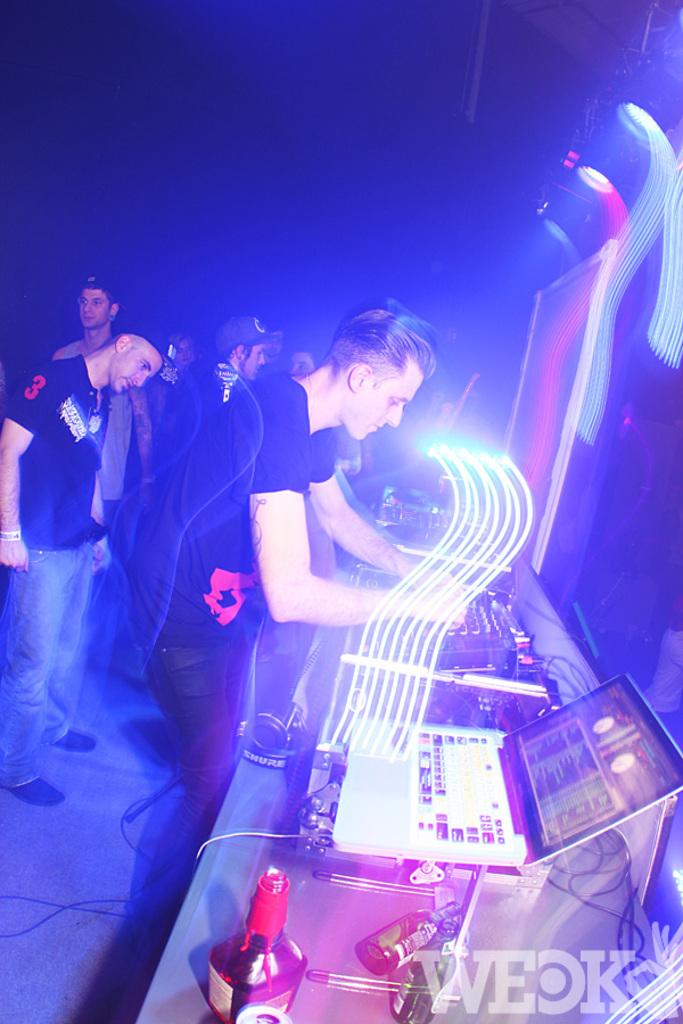How many people are in the image? There is a group of people in the image, but the exact number is not specified. What are the people in the image doing? The group of people is standing in the image. What objects are in front of the group of people? There is a laptop, bottles, and a machine in front of the group of people. What can be observed about the background of the image? The background of the image is dark. How many passengers are sitting on the seat in the image? There is no seat or passenger present in the image. What type of joke is being told by the group of people in the image? There is no indication of a joke being told in the image. 